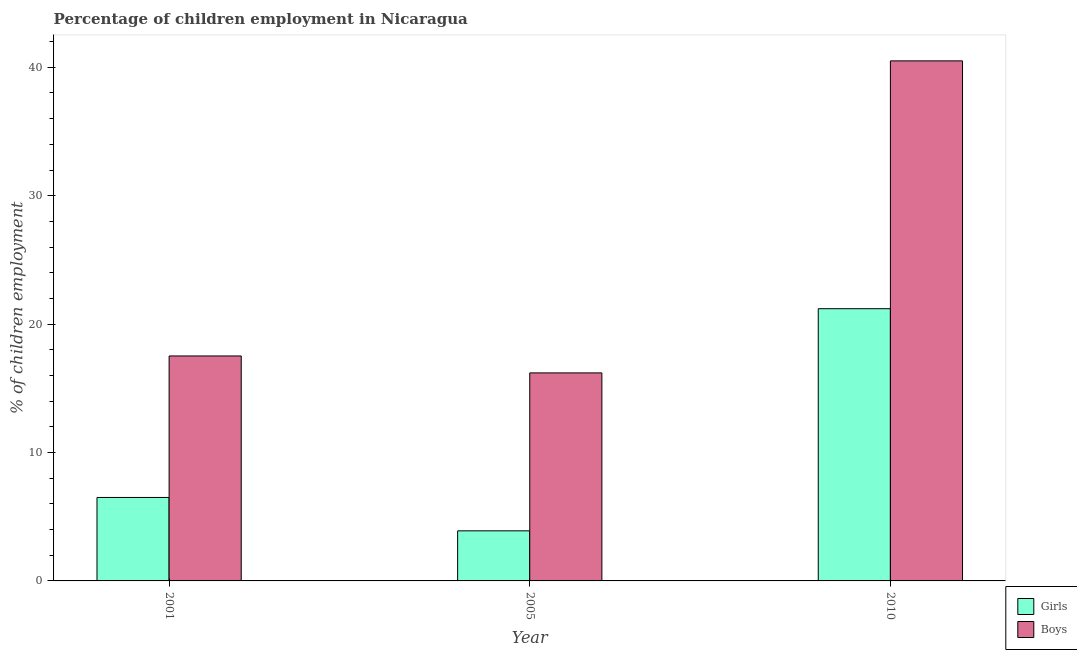How many different coloured bars are there?
Your answer should be very brief. 2. How many bars are there on the 3rd tick from the left?
Your response must be concise. 2. In how many cases, is the number of bars for a given year not equal to the number of legend labels?
Provide a short and direct response. 0. Across all years, what is the maximum percentage of employed boys?
Provide a short and direct response. 40.5. Across all years, what is the minimum percentage of employed girls?
Ensure brevity in your answer.  3.9. In which year was the percentage of employed girls maximum?
Provide a short and direct response. 2010. What is the total percentage of employed girls in the graph?
Give a very brief answer. 31.6. What is the difference between the percentage of employed girls in 2001 and that in 2005?
Offer a terse response. 2.6. What is the difference between the percentage of employed girls in 2001 and the percentage of employed boys in 2010?
Offer a very short reply. -14.7. What is the average percentage of employed girls per year?
Your response must be concise. 10.53. In how many years, is the percentage of employed boys greater than 36 %?
Offer a very short reply. 1. What is the ratio of the percentage of employed girls in 2001 to that in 2010?
Provide a short and direct response. 0.31. Is the difference between the percentage of employed girls in 2001 and 2005 greater than the difference between the percentage of employed boys in 2001 and 2005?
Your answer should be compact. No. What is the difference between the highest and the second highest percentage of employed boys?
Keep it short and to the point. 22.98. What does the 1st bar from the left in 2001 represents?
Give a very brief answer. Girls. What does the 2nd bar from the right in 2010 represents?
Give a very brief answer. Girls. How many bars are there?
Ensure brevity in your answer.  6. How many years are there in the graph?
Your answer should be compact. 3. Are the values on the major ticks of Y-axis written in scientific E-notation?
Ensure brevity in your answer.  No. Does the graph contain grids?
Your answer should be very brief. No. How many legend labels are there?
Your answer should be very brief. 2. What is the title of the graph?
Provide a succinct answer. Percentage of children employment in Nicaragua. Does "From Government" appear as one of the legend labels in the graph?
Provide a short and direct response. No. What is the label or title of the Y-axis?
Your answer should be very brief. % of children employment. What is the % of children employment of Girls in 2001?
Give a very brief answer. 6.5. What is the % of children employment of Boys in 2001?
Your response must be concise. 17.52. What is the % of children employment in Girls in 2005?
Keep it short and to the point. 3.9. What is the % of children employment of Boys in 2005?
Your answer should be very brief. 16.2. What is the % of children employment of Girls in 2010?
Give a very brief answer. 21.2. What is the % of children employment of Boys in 2010?
Your answer should be very brief. 40.5. Across all years, what is the maximum % of children employment of Girls?
Ensure brevity in your answer.  21.2. Across all years, what is the maximum % of children employment of Boys?
Offer a very short reply. 40.5. Across all years, what is the minimum % of children employment of Boys?
Give a very brief answer. 16.2. What is the total % of children employment of Girls in the graph?
Offer a terse response. 31.6. What is the total % of children employment in Boys in the graph?
Your answer should be very brief. 74.22. What is the difference between the % of children employment of Girls in 2001 and that in 2005?
Keep it short and to the point. 2.6. What is the difference between the % of children employment of Boys in 2001 and that in 2005?
Offer a very short reply. 1.32. What is the difference between the % of children employment in Girls in 2001 and that in 2010?
Offer a very short reply. -14.7. What is the difference between the % of children employment of Boys in 2001 and that in 2010?
Offer a very short reply. -22.98. What is the difference between the % of children employment of Girls in 2005 and that in 2010?
Provide a succinct answer. -17.3. What is the difference between the % of children employment of Boys in 2005 and that in 2010?
Offer a terse response. -24.3. What is the difference between the % of children employment of Girls in 2001 and the % of children employment of Boys in 2005?
Your answer should be very brief. -9.7. What is the difference between the % of children employment of Girls in 2001 and the % of children employment of Boys in 2010?
Provide a succinct answer. -34. What is the difference between the % of children employment in Girls in 2005 and the % of children employment in Boys in 2010?
Offer a terse response. -36.6. What is the average % of children employment in Girls per year?
Give a very brief answer. 10.53. What is the average % of children employment of Boys per year?
Your answer should be very brief. 24.74. In the year 2001, what is the difference between the % of children employment of Girls and % of children employment of Boys?
Your answer should be compact. -11.02. In the year 2005, what is the difference between the % of children employment in Girls and % of children employment in Boys?
Ensure brevity in your answer.  -12.3. In the year 2010, what is the difference between the % of children employment in Girls and % of children employment in Boys?
Offer a very short reply. -19.3. What is the ratio of the % of children employment of Girls in 2001 to that in 2005?
Make the answer very short. 1.67. What is the ratio of the % of children employment in Boys in 2001 to that in 2005?
Ensure brevity in your answer.  1.08. What is the ratio of the % of children employment in Girls in 2001 to that in 2010?
Your answer should be compact. 0.31. What is the ratio of the % of children employment in Boys in 2001 to that in 2010?
Offer a very short reply. 0.43. What is the ratio of the % of children employment of Girls in 2005 to that in 2010?
Keep it short and to the point. 0.18. What is the difference between the highest and the second highest % of children employment of Girls?
Your answer should be compact. 14.7. What is the difference between the highest and the second highest % of children employment of Boys?
Make the answer very short. 22.98. What is the difference between the highest and the lowest % of children employment of Girls?
Offer a very short reply. 17.3. What is the difference between the highest and the lowest % of children employment in Boys?
Your answer should be very brief. 24.3. 